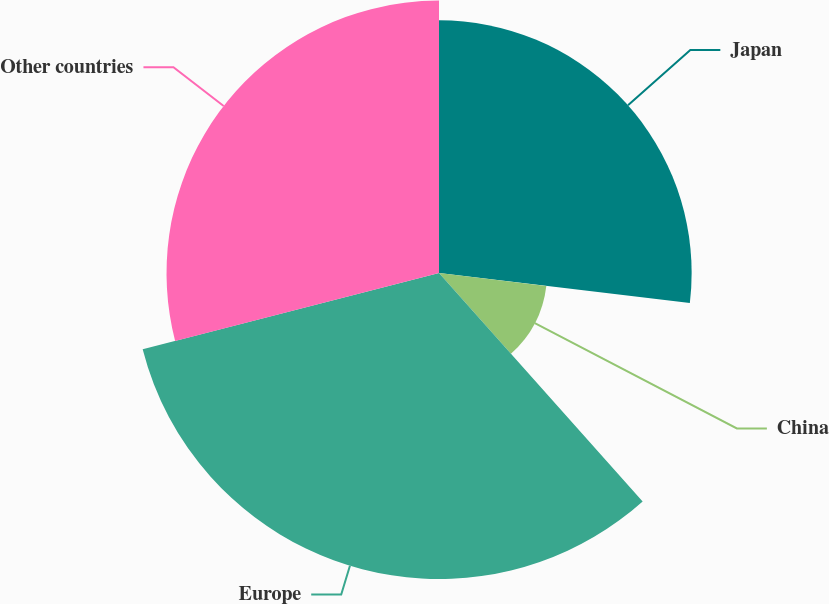Convert chart to OTSL. <chart><loc_0><loc_0><loc_500><loc_500><pie_chart><fcel>Japan<fcel>China<fcel>Europe<fcel>Other countries<nl><fcel>26.9%<fcel>11.51%<fcel>32.58%<fcel>29.01%<nl></chart> 